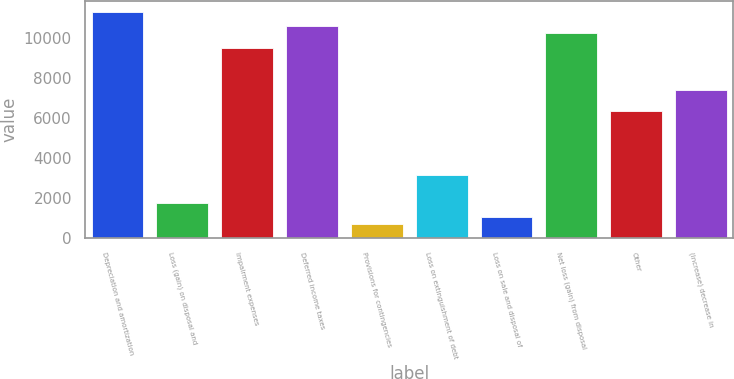<chart> <loc_0><loc_0><loc_500><loc_500><bar_chart><fcel>Depreciation and amortization<fcel>Loss (gain) on disposal and<fcel>Impairment expenses<fcel>Deferred income taxes<fcel>Provisions for contingencies<fcel>Loss on extinguishment of debt<fcel>Loss on sale and disposal of<fcel>Net loss (gain) from disposal<fcel>Other<fcel>(Increase) decrease in<nl><fcel>11310.4<fcel>1774<fcel>9544.4<fcel>10604<fcel>714.4<fcel>3186.8<fcel>1067.6<fcel>10250.8<fcel>6365.6<fcel>7425.2<nl></chart> 